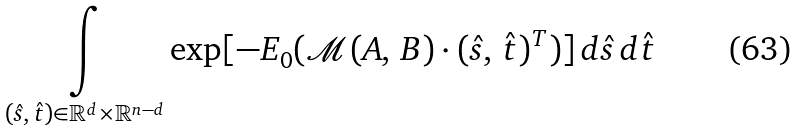<formula> <loc_0><loc_0><loc_500><loc_500>& \underset { ( \hat { s } , \, \hat { t } ) \in \mathbb { R } ^ { d } \times \mathbb { R } ^ { n - d } } { \int } \exp [ - E _ { 0 } ( \mathcal { M } ( A , \, B ) \cdot ( \hat { s } , \, \hat { t } ) ^ { T } ) ] \, d \hat { s } \, d \hat { t }</formula> 